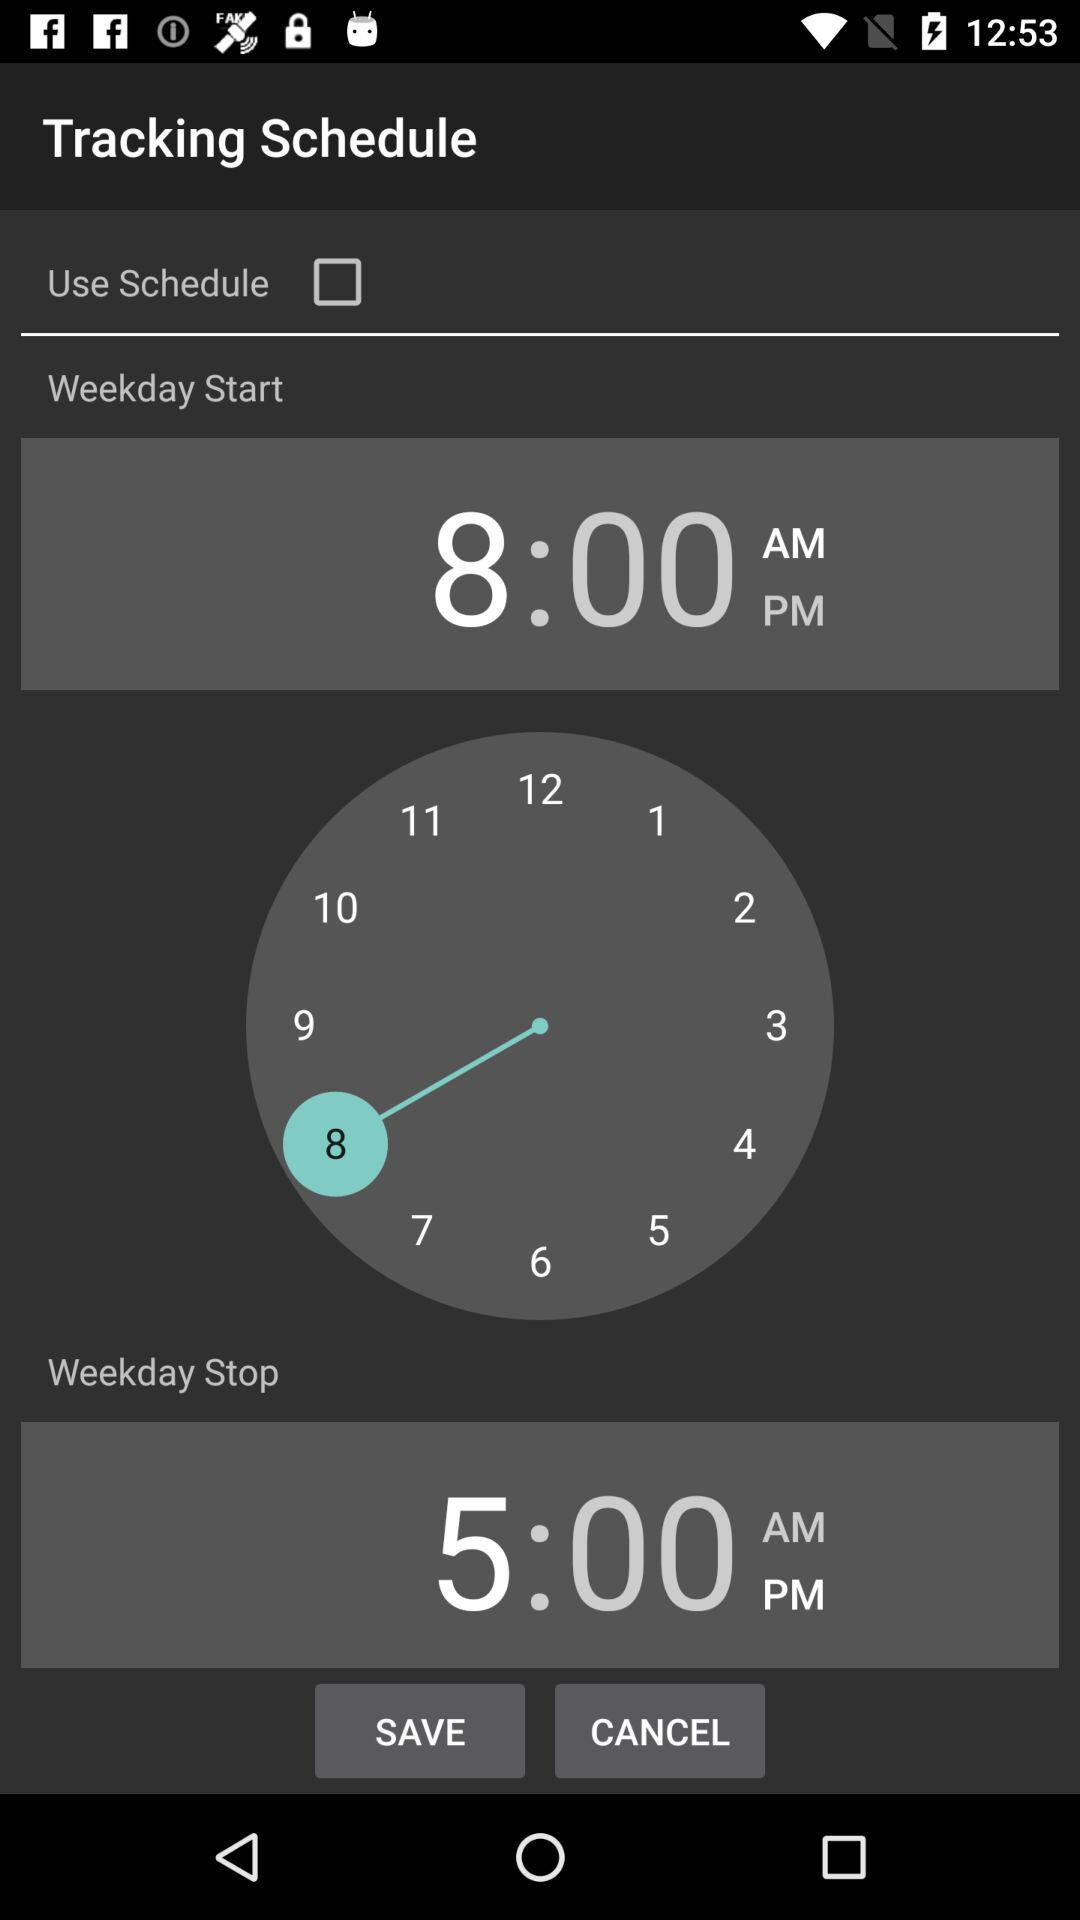What is the status of the "Use Schedule"? The status is "off". 